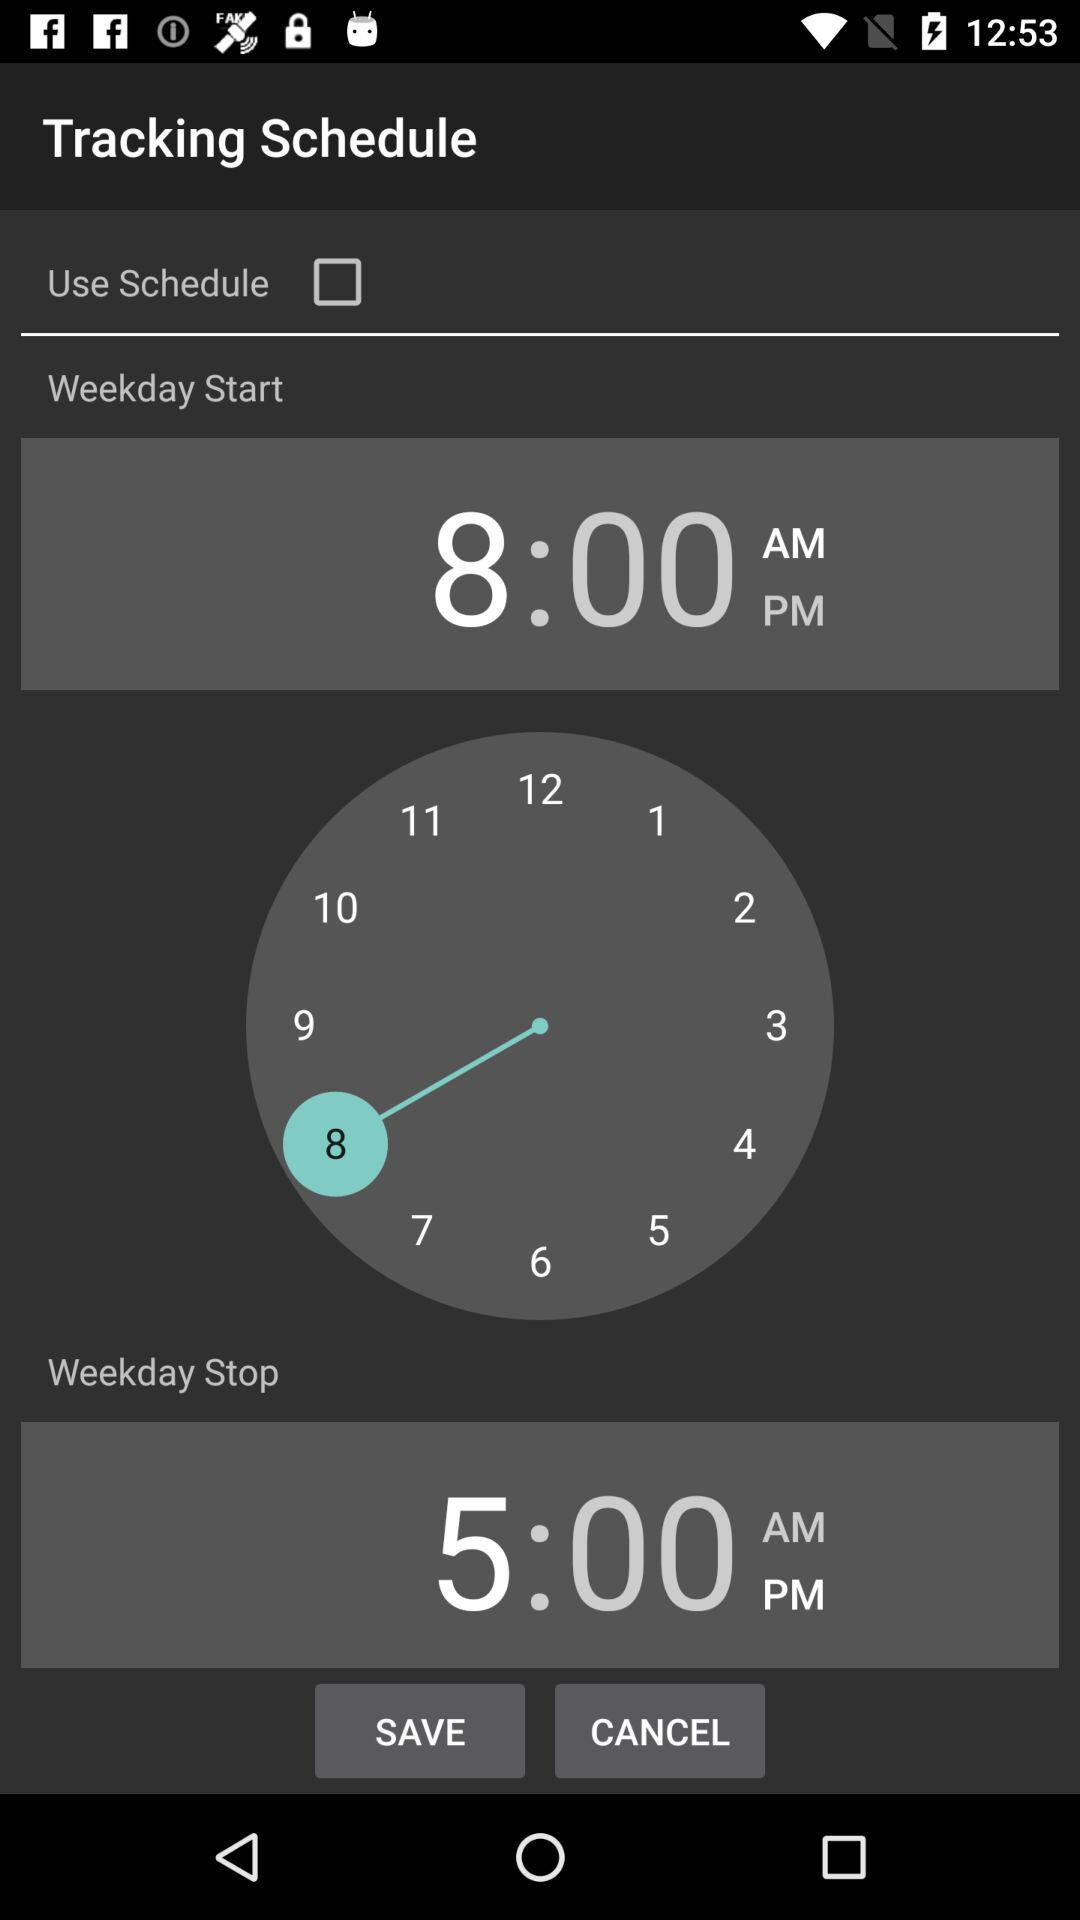What is the status of the "Use Schedule"? The status is "off". 